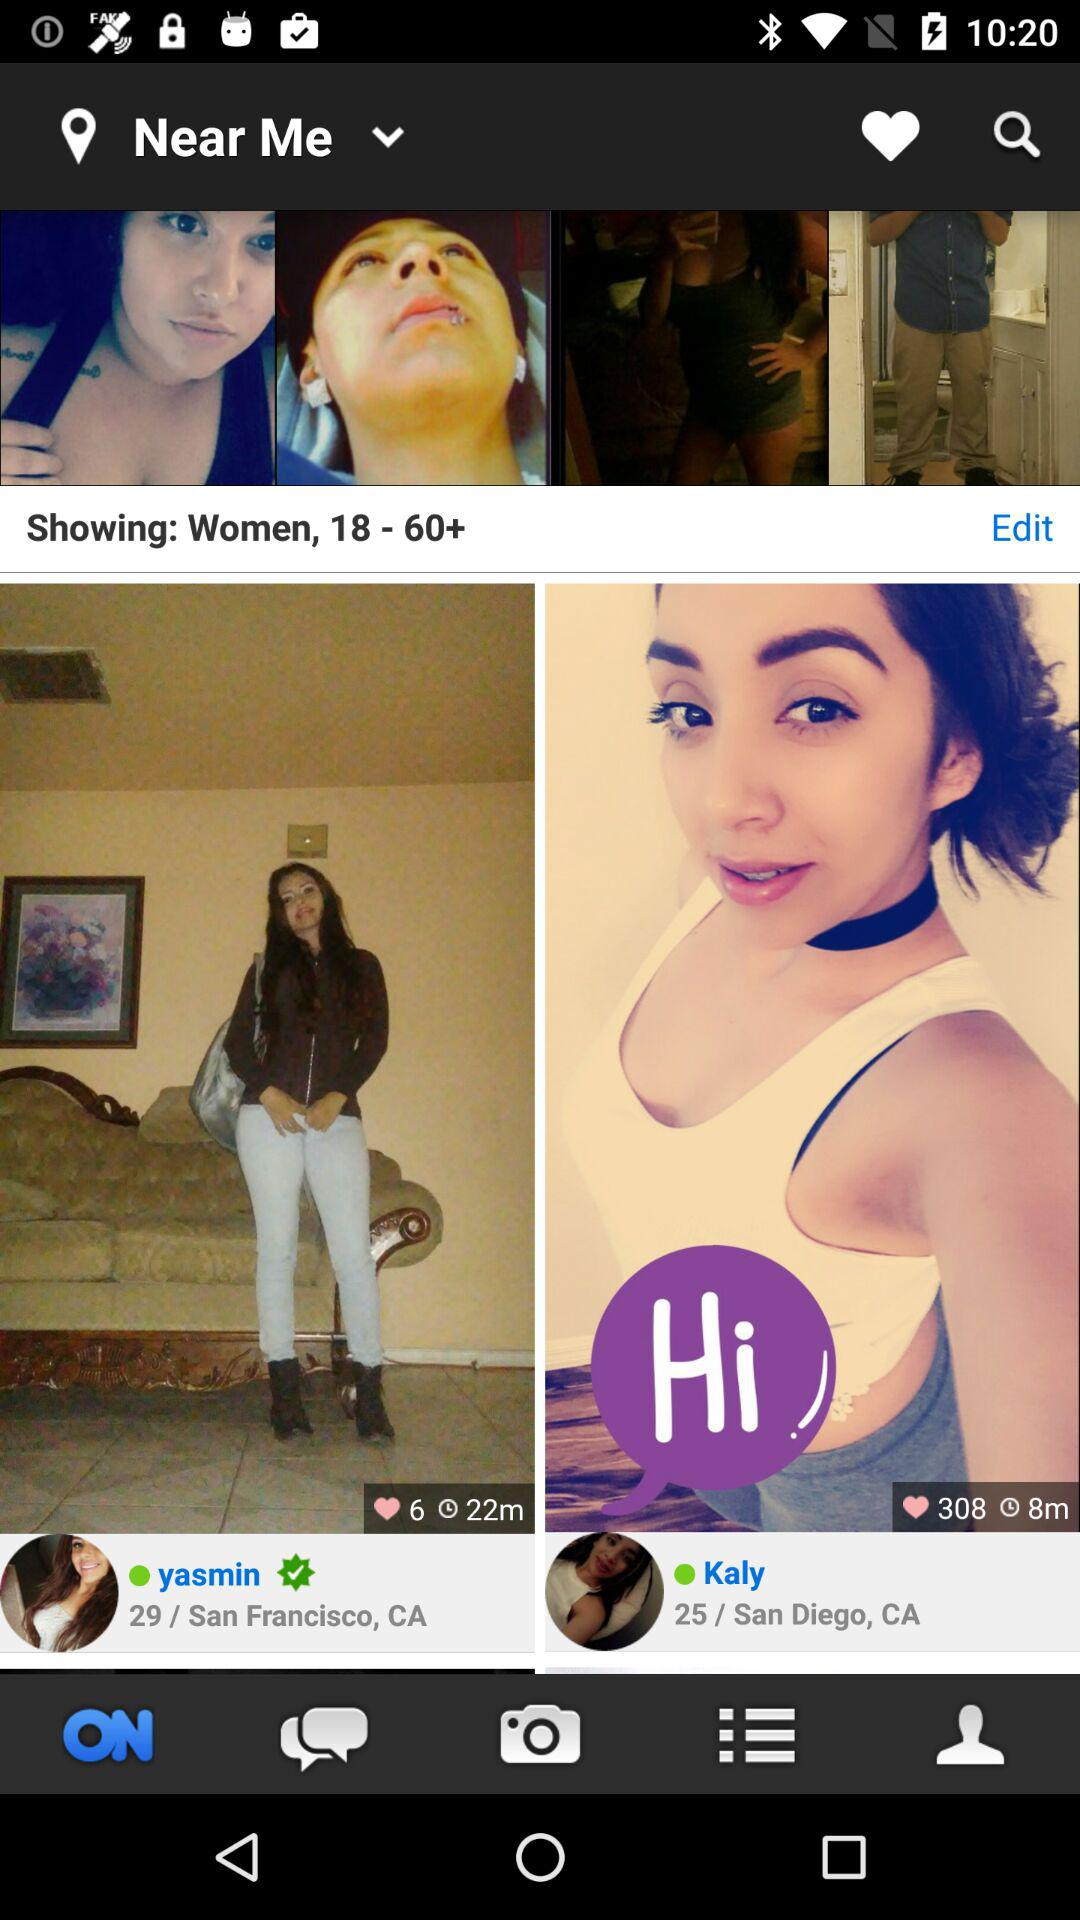What is the women's age range mentioned on the screen? The mentioned age range is from 18 to 60+. 